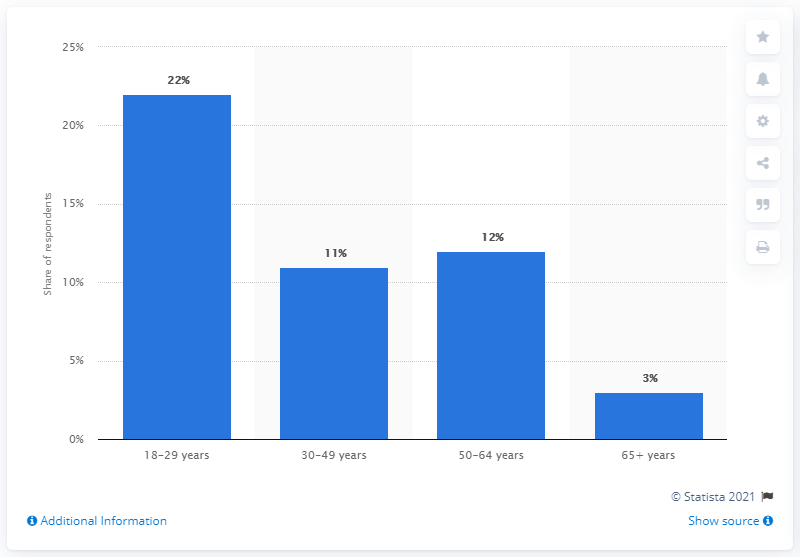Identify some key points in this picture. According to data from July 2019, the age group of 65 years and older had the lowest percentage of individuals in the United States who reported smoking marijuana. In the United States, consumers aged 18-29 years had the highest number of marijuana smokers as of July 2019. 